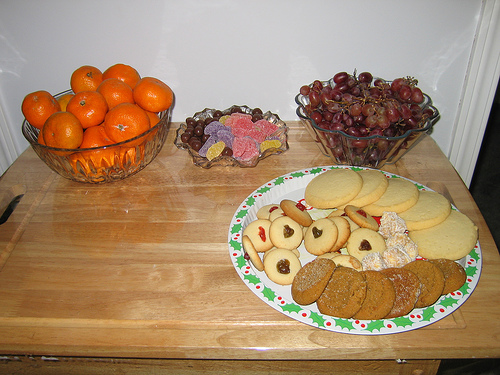<image>
Is there a grapes to the left of the cookies? No. The grapes is not to the left of the cookies. From this viewpoint, they have a different horizontal relationship. 